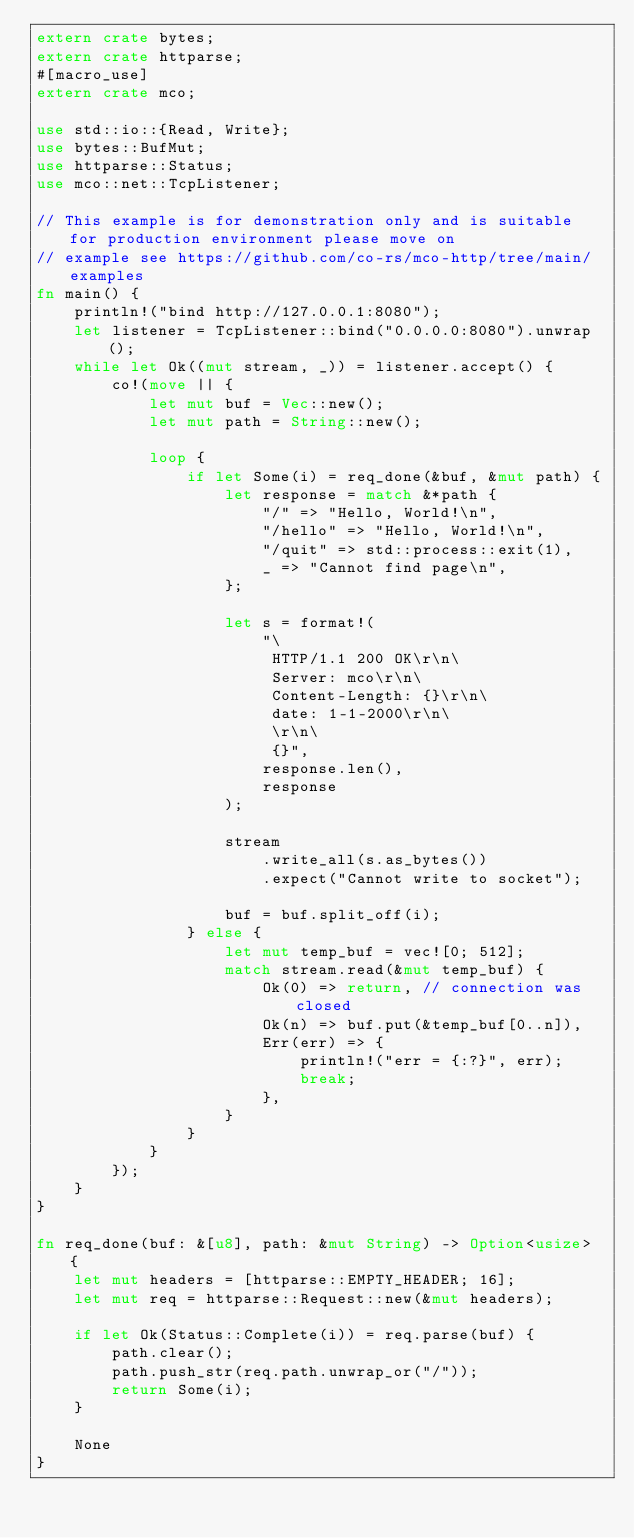Convert code to text. <code><loc_0><loc_0><loc_500><loc_500><_Rust_>extern crate bytes;
extern crate httparse;
#[macro_use]
extern crate mco;

use std::io::{Read, Write};
use bytes::BufMut;
use httparse::Status;
use mco::net::TcpListener;

// This example is for demonstration only and is suitable for production environment please move on
// example see https://github.com/co-rs/mco-http/tree/main/examples
fn main() {
    println!("bind http://127.0.0.1:8080");
    let listener = TcpListener::bind("0.0.0.0:8080").unwrap();
    while let Ok((mut stream, _)) = listener.accept() {
        co!(move || {
            let mut buf = Vec::new();
            let mut path = String::new();

            loop {
                if let Some(i) = req_done(&buf, &mut path) {
                    let response = match &*path {
                        "/" => "Hello, World!\n",
                        "/hello" => "Hello, World!\n",
                        "/quit" => std::process::exit(1),
                        _ => "Cannot find page\n",
                    };

                    let s = format!(
                        "\
                         HTTP/1.1 200 OK\r\n\
                         Server: mco\r\n\
                         Content-Length: {}\r\n\
                         date: 1-1-2000\r\n\
                         \r\n\
                         {}",
                        response.len(),
                        response
                    );

                    stream
                        .write_all(s.as_bytes())
                        .expect("Cannot write to socket");

                    buf = buf.split_off(i);
                } else {
                    let mut temp_buf = vec![0; 512];
                    match stream.read(&mut temp_buf) {
                        Ok(0) => return, // connection was closed
                        Ok(n) => buf.put(&temp_buf[0..n]),
                        Err(err) => {
                            println!("err = {:?}", err);
                            break;
                        },
                    }
                }
            }
        });
    }
}

fn req_done(buf: &[u8], path: &mut String) -> Option<usize> {
    let mut headers = [httparse::EMPTY_HEADER; 16];
    let mut req = httparse::Request::new(&mut headers);

    if let Ok(Status::Complete(i)) = req.parse(buf) {
        path.clear();
        path.push_str(req.path.unwrap_or("/"));
        return Some(i);
    }

    None
}
</code> 